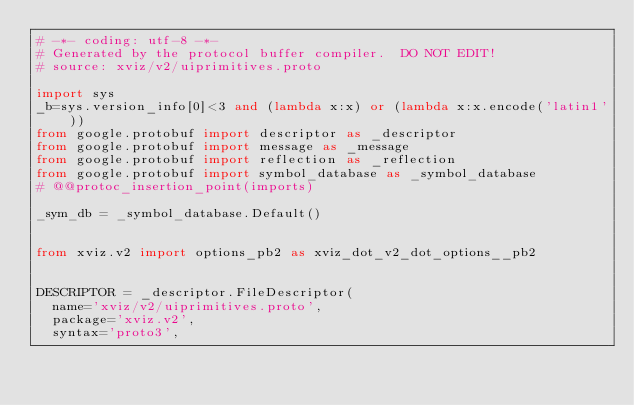<code> <loc_0><loc_0><loc_500><loc_500><_Python_># -*- coding: utf-8 -*-
# Generated by the protocol buffer compiler.  DO NOT EDIT!
# source: xviz/v2/uiprimitives.proto

import sys
_b=sys.version_info[0]<3 and (lambda x:x) or (lambda x:x.encode('latin1'))
from google.protobuf import descriptor as _descriptor
from google.protobuf import message as _message
from google.protobuf import reflection as _reflection
from google.protobuf import symbol_database as _symbol_database
# @@protoc_insertion_point(imports)

_sym_db = _symbol_database.Default()


from xviz.v2 import options_pb2 as xviz_dot_v2_dot_options__pb2


DESCRIPTOR = _descriptor.FileDescriptor(
  name='xviz/v2/uiprimitives.proto',
  package='xviz.v2',
  syntax='proto3',</code> 